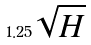Convert formula to latex. <formula><loc_0><loc_0><loc_500><loc_500>1 . 2 5 \sqrt { H }</formula> 